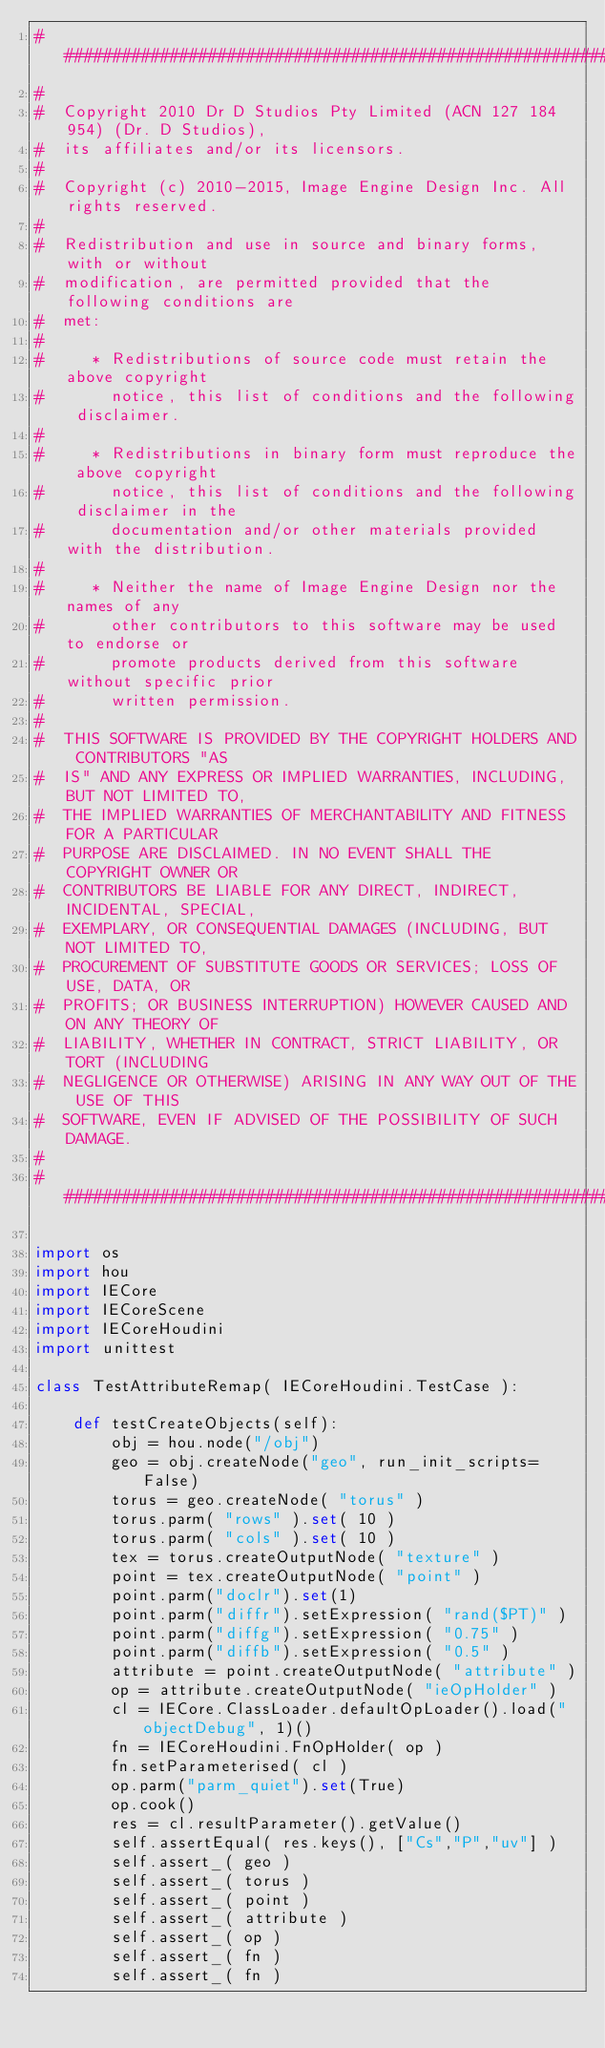Convert code to text. <code><loc_0><loc_0><loc_500><loc_500><_Python_>##########################################################################
#
#  Copyright 2010 Dr D Studios Pty Limited (ACN 127 184 954) (Dr. D Studios),
#  its affiliates and/or its licensors.
#
#  Copyright (c) 2010-2015, Image Engine Design Inc. All rights reserved.
#
#  Redistribution and use in source and binary forms, with or without
#  modification, are permitted provided that the following conditions are
#  met:
#
#     * Redistributions of source code must retain the above copyright
#       notice, this list of conditions and the following disclaimer.
#
#     * Redistributions in binary form must reproduce the above copyright
#       notice, this list of conditions and the following disclaimer in the
#       documentation and/or other materials provided with the distribution.
#
#     * Neither the name of Image Engine Design nor the names of any
#       other contributors to this software may be used to endorse or
#       promote products derived from this software without specific prior
#       written permission.
#
#  THIS SOFTWARE IS PROVIDED BY THE COPYRIGHT HOLDERS AND CONTRIBUTORS "AS
#  IS" AND ANY EXPRESS OR IMPLIED WARRANTIES, INCLUDING, BUT NOT LIMITED TO,
#  THE IMPLIED WARRANTIES OF MERCHANTABILITY AND FITNESS FOR A PARTICULAR
#  PURPOSE ARE DISCLAIMED. IN NO EVENT SHALL THE COPYRIGHT OWNER OR
#  CONTRIBUTORS BE LIABLE FOR ANY DIRECT, INDIRECT, INCIDENTAL, SPECIAL,
#  EXEMPLARY, OR CONSEQUENTIAL DAMAGES (INCLUDING, BUT NOT LIMITED TO,
#  PROCUREMENT OF SUBSTITUTE GOODS OR SERVICES; LOSS OF USE, DATA, OR
#  PROFITS; OR BUSINESS INTERRUPTION) HOWEVER CAUSED AND ON ANY THEORY OF
#  LIABILITY, WHETHER IN CONTRACT, STRICT LIABILITY, OR TORT (INCLUDING
#  NEGLIGENCE OR OTHERWISE) ARISING IN ANY WAY OUT OF THE USE OF THIS
#  SOFTWARE, EVEN IF ADVISED OF THE POSSIBILITY OF SUCH DAMAGE.
#
##########################################################################

import os
import hou
import IECore
import IECoreScene
import IECoreHoudini
import unittest

class TestAttributeRemap( IECoreHoudini.TestCase ):

	def testCreateObjects(self):
		obj = hou.node("/obj")
		geo = obj.createNode("geo", run_init_scripts=False)
		torus = geo.createNode( "torus" )
		torus.parm( "rows" ).set( 10 )
		torus.parm( "cols" ).set( 10 )
		tex = torus.createOutputNode( "texture" )
		point = tex.createOutputNode( "point" )
		point.parm("doclr").set(1)
		point.parm("diffr").setExpression( "rand($PT)" )
		point.parm("diffg").setExpression( "0.75" )
		point.parm("diffb").setExpression( "0.5" )
		attribute = point.createOutputNode( "attribute" )
		op = attribute.createOutputNode( "ieOpHolder" )
		cl = IECore.ClassLoader.defaultOpLoader().load("objectDebug", 1)()
		fn = IECoreHoudini.FnOpHolder( op )
		fn.setParameterised( cl )
		op.parm("parm_quiet").set(True)
		op.cook()
		res = cl.resultParameter().getValue()
		self.assertEqual( res.keys(), ["Cs","P","uv"] )
		self.assert_( geo )
		self.assert_( torus )
		self.assert_( point )
		self.assert_( attribute )
		self.assert_( op )
		self.assert_( fn )
		self.assert_( fn )</code> 